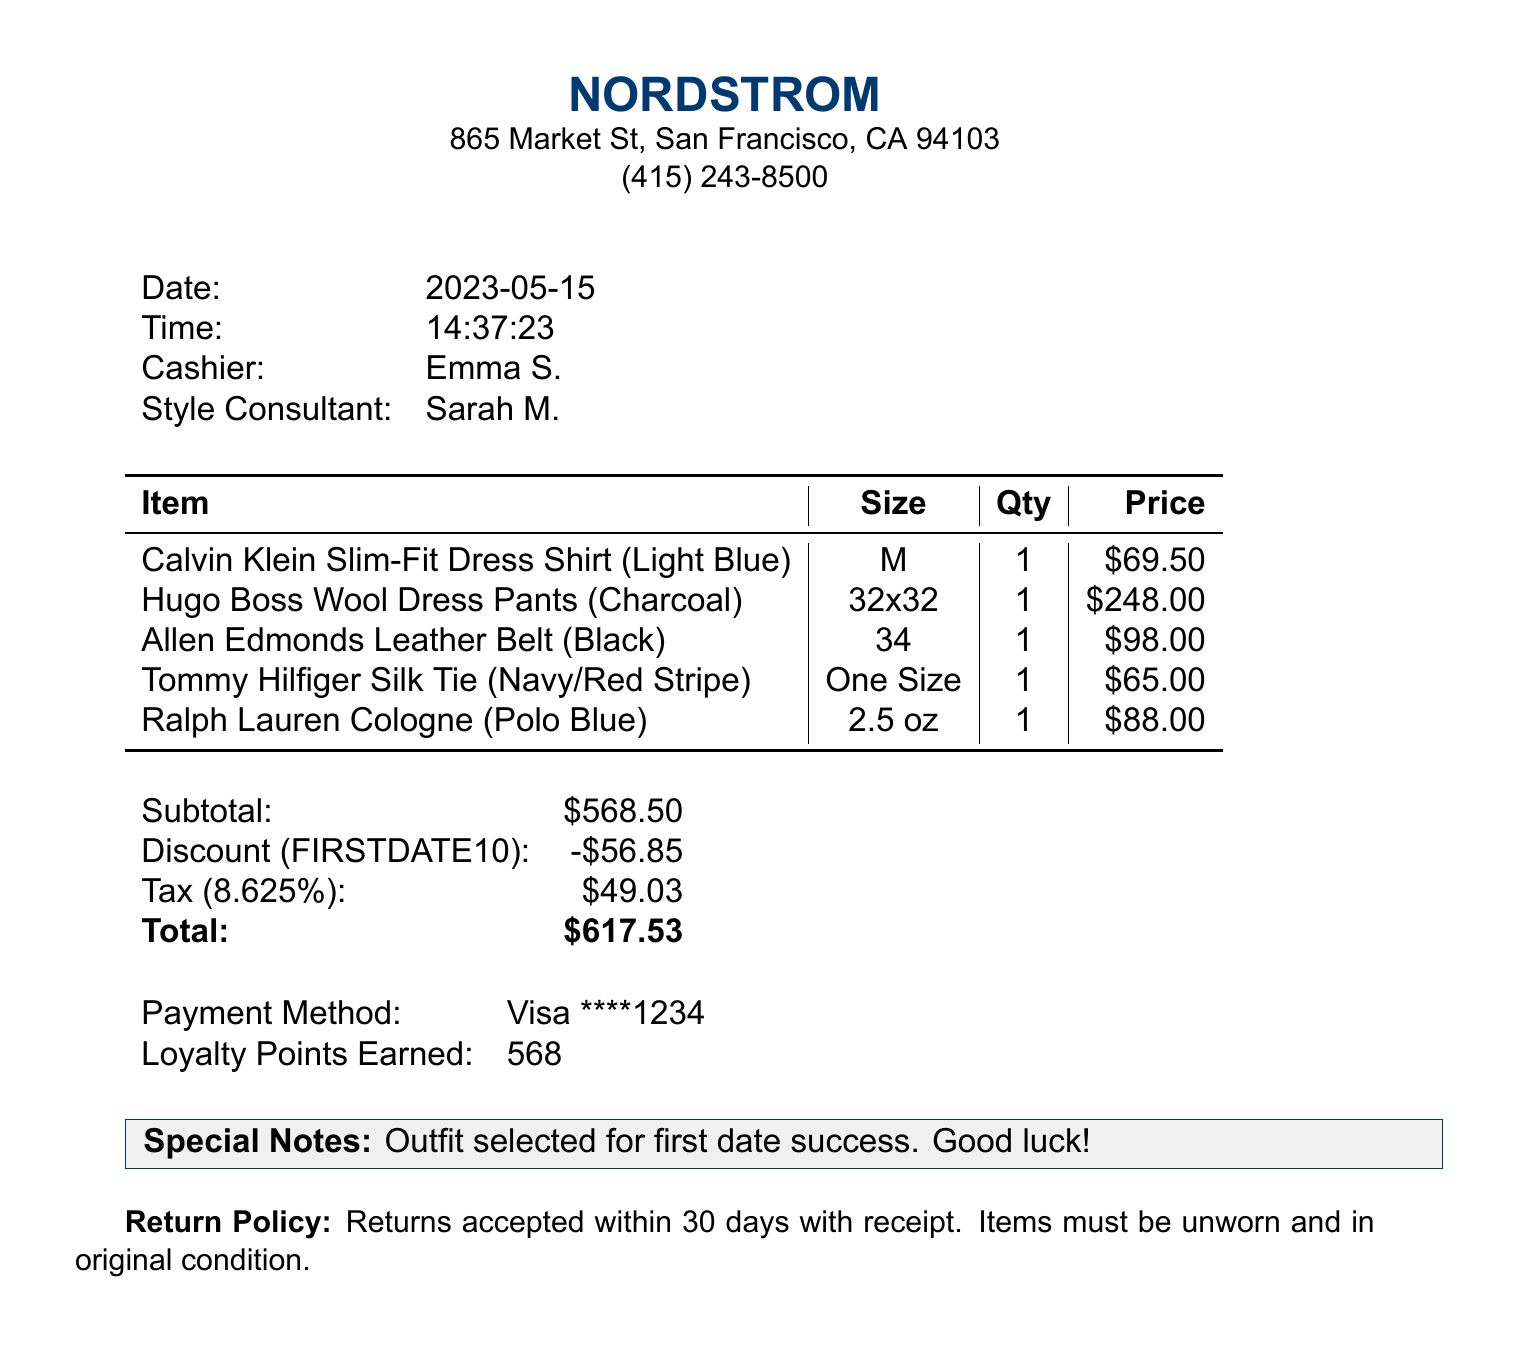What is the store name? The store name is listed at the top of the document.
Answer: Nordstrom What is the total amount spent? The total amount is calculated at the end of the receipt.
Answer: $617.53 What is the color of the dress shirt? The color is mentioned next to the item description.
Answer: Light Blue Who was the cashier during the purchase? The cashier's name is provided in the transaction details.
Answer: Emma S What is the discount amount applied? The discount amount is specifically mentioned in the subtotal section.
Answer: $56.85 What is the return policy period? The return policy is stated in the last section of the document.
Answer: 30 days How many loyalty points were earned? The number of loyalty points is noted in the payment section.
Answer: 568 What size were the dress pants purchased? The size of the dress pants is included in the item details.
Answer: 32x32 What is the promotional code used for the purchase? The promotional code is listed in the discount section of the receipt.
Answer: FIRSTDATE10 